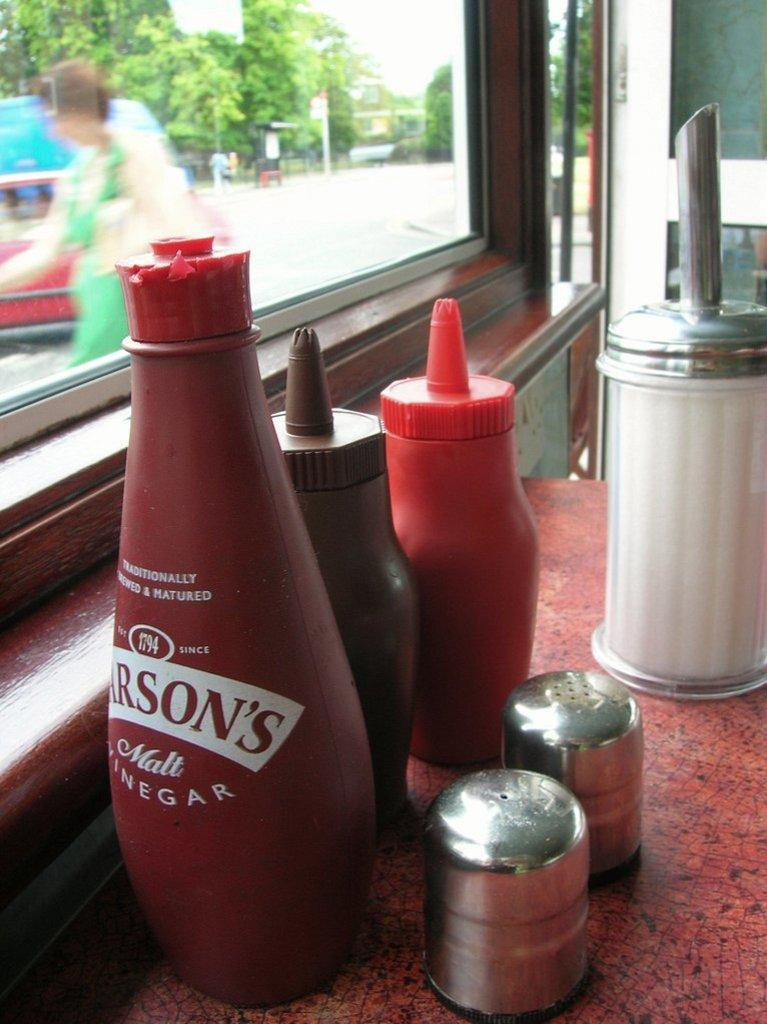What objects are on the table in the image? There are bottles on the table in the image. How many types of bottles are present? There are different types of bottles in the image. What can be seen through the window in the image? A person and trees are visible outside the window in the image. What type of blade is being used by the ducks in the image? There are no ducks present in the image, and therefore no blades or duck-related activities can be observed. 